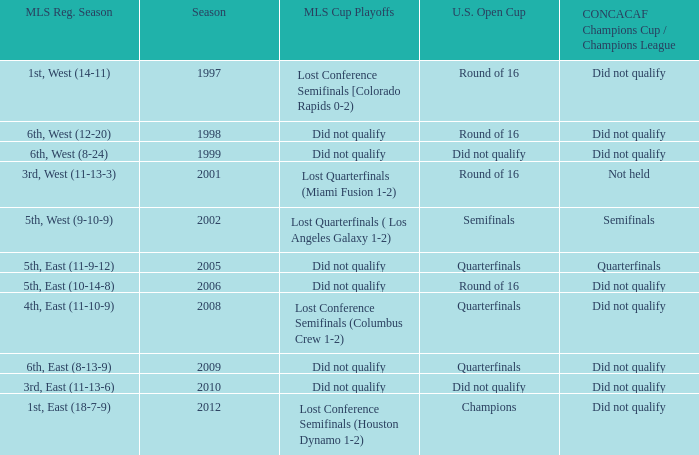When was the first season? 1997.0. 